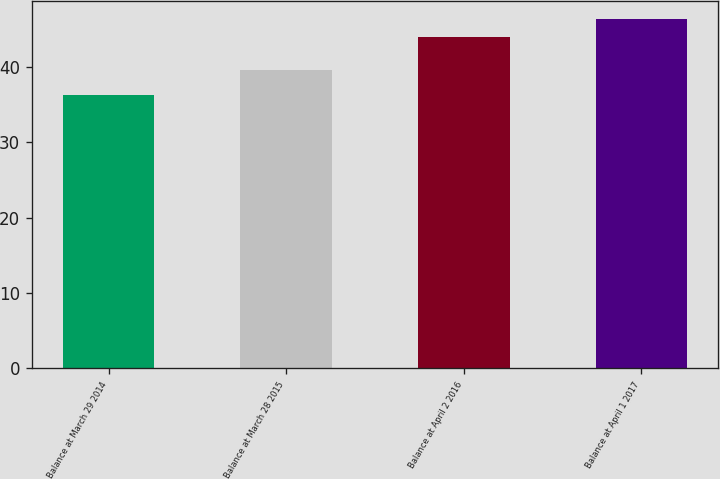Convert chart to OTSL. <chart><loc_0><loc_0><loc_500><loc_500><bar_chart><fcel>Balance at March 29 2014<fcel>Balance at March 28 2015<fcel>Balance at April 2 2016<fcel>Balance at April 1 2017<nl><fcel>36.2<fcel>39.6<fcel>44<fcel>46.4<nl></chart> 